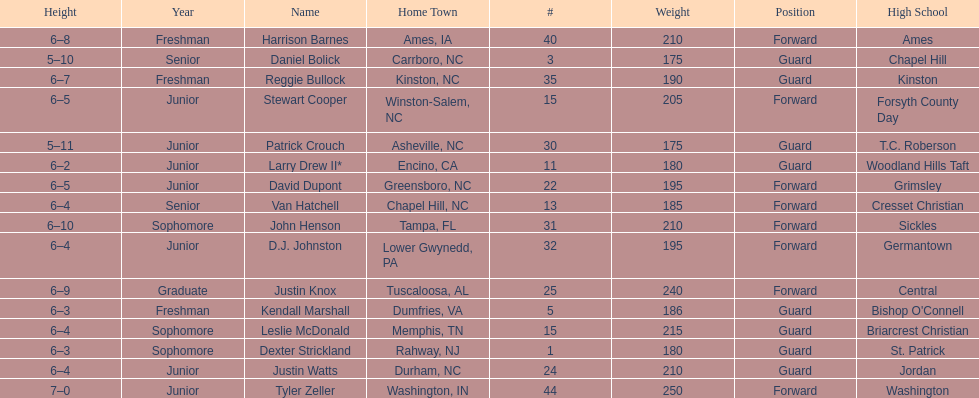Names of players who were exactly 6 feet, 4 inches tall, but did not weight over 200 pounds Van Hatchell, D.J. Johnston. 